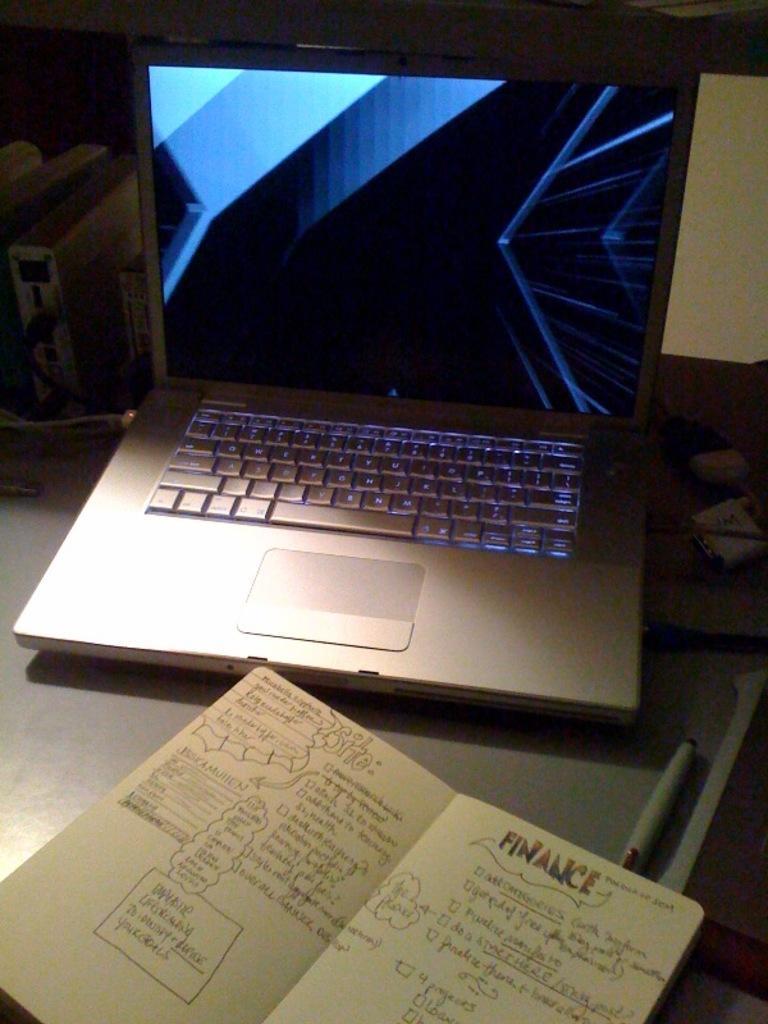In one or two sentences, can you explain what this image depicts? In this image we can see a table on which a laptop, book and a marker are there. 